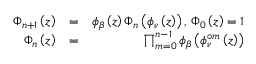<formula> <loc_0><loc_0><loc_500><loc_500>\begin{array} { r l r } { \Phi _ { n + 1 } \left ( z \right ) } & { = } & { \phi _ { \beta } \left ( z \right ) \Phi _ { n } \left ( \phi _ { \nu } \left ( z \right ) \right ) , \Phi _ { 0 } \left ( z \right ) = 1 } \\ { \Phi _ { n } \left ( z \right ) } & { = } & { \prod _ { m = 0 } ^ { n - 1 } \phi _ { \beta } \left ( \phi _ { \nu } ^ { \circ m } \left ( z \right ) \right ) } \end{array}</formula> 